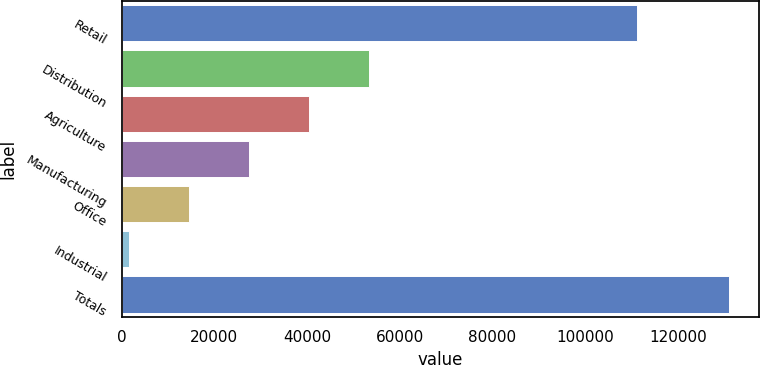<chart> <loc_0><loc_0><loc_500><loc_500><bar_chart><fcel>Retail<fcel>Distribution<fcel>Agriculture<fcel>Manufacturing<fcel>Office<fcel>Industrial<fcel>Totals<nl><fcel>111218<fcel>53318.8<fcel>40381.6<fcel>27444.4<fcel>14507.2<fcel>1570<fcel>130942<nl></chart> 